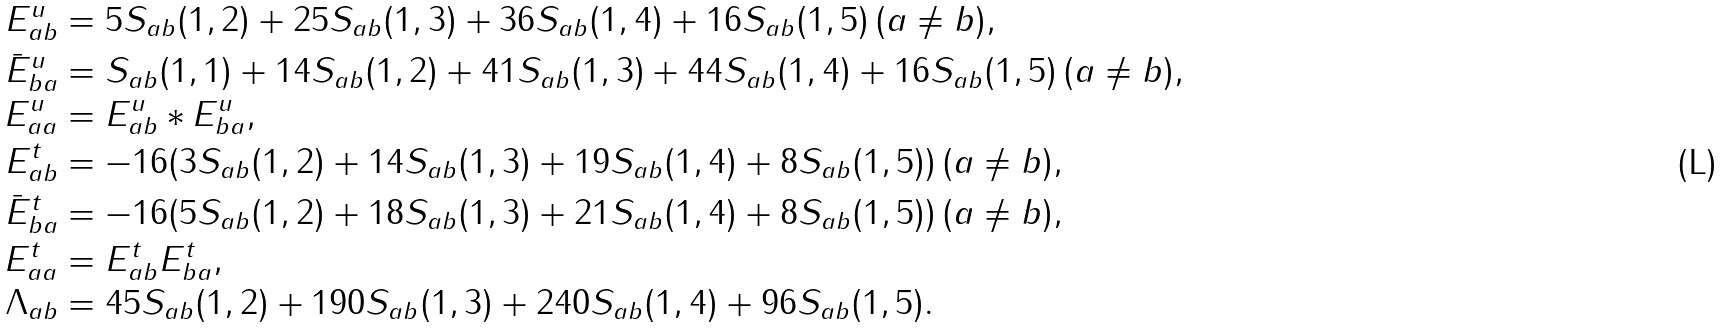Convert formula to latex. <formula><loc_0><loc_0><loc_500><loc_500>E ^ { u } _ { a b } & = 5 S _ { a b } ( 1 , 2 ) + 2 5 S _ { a b } ( 1 , 3 ) + 3 6 S _ { a b } ( 1 , 4 ) + 1 6 S _ { a b } ( 1 , 5 ) \, ( a \neq b ) , \\ \bar { E } ^ { u } _ { b a } & = S _ { a b } ( 1 , 1 ) + 1 4 S _ { a b } ( 1 , 2 ) + 4 1 S _ { a b } ( 1 , 3 ) + 4 4 S _ { a b } ( 1 , 4 ) + 1 6 S _ { a b } ( 1 , 5 ) \, ( a \neq b ) , \\ E _ { a a } ^ { u } & = E ^ { u } _ { a b } * E ^ { u } _ { b a } , \\ E ^ { t } _ { a b } & = - 1 6 ( 3 S _ { a b } ( 1 , 2 ) + 1 4 S _ { a b } ( 1 , 3 ) + 1 9 S _ { a b } ( 1 , 4 ) + 8 S _ { a b } ( 1 , 5 ) ) \, ( a \neq b ) , \\ \bar { E } ^ { t } _ { b a } & = - 1 6 ( 5 S _ { a b } ( 1 , 2 ) + 1 8 S _ { a b } ( 1 , 3 ) + 2 1 S _ { a b } ( 1 , 4 ) + 8 S _ { a b } ( 1 , 5 ) ) \, ( a \neq b ) , \\ E _ { a a } ^ { t } & = E ^ { t } _ { a b } E ^ { t } _ { b a } , \\ \Lambda _ { a b } & = 4 5 S _ { a b } ( 1 , 2 ) + 1 9 0 S _ { a b } ( 1 , 3 ) + 2 4 0 S _ { a b } ( 1 , 4 ) + 9 6 S _ { a b } ( 1 , 5 ) .</formula> 